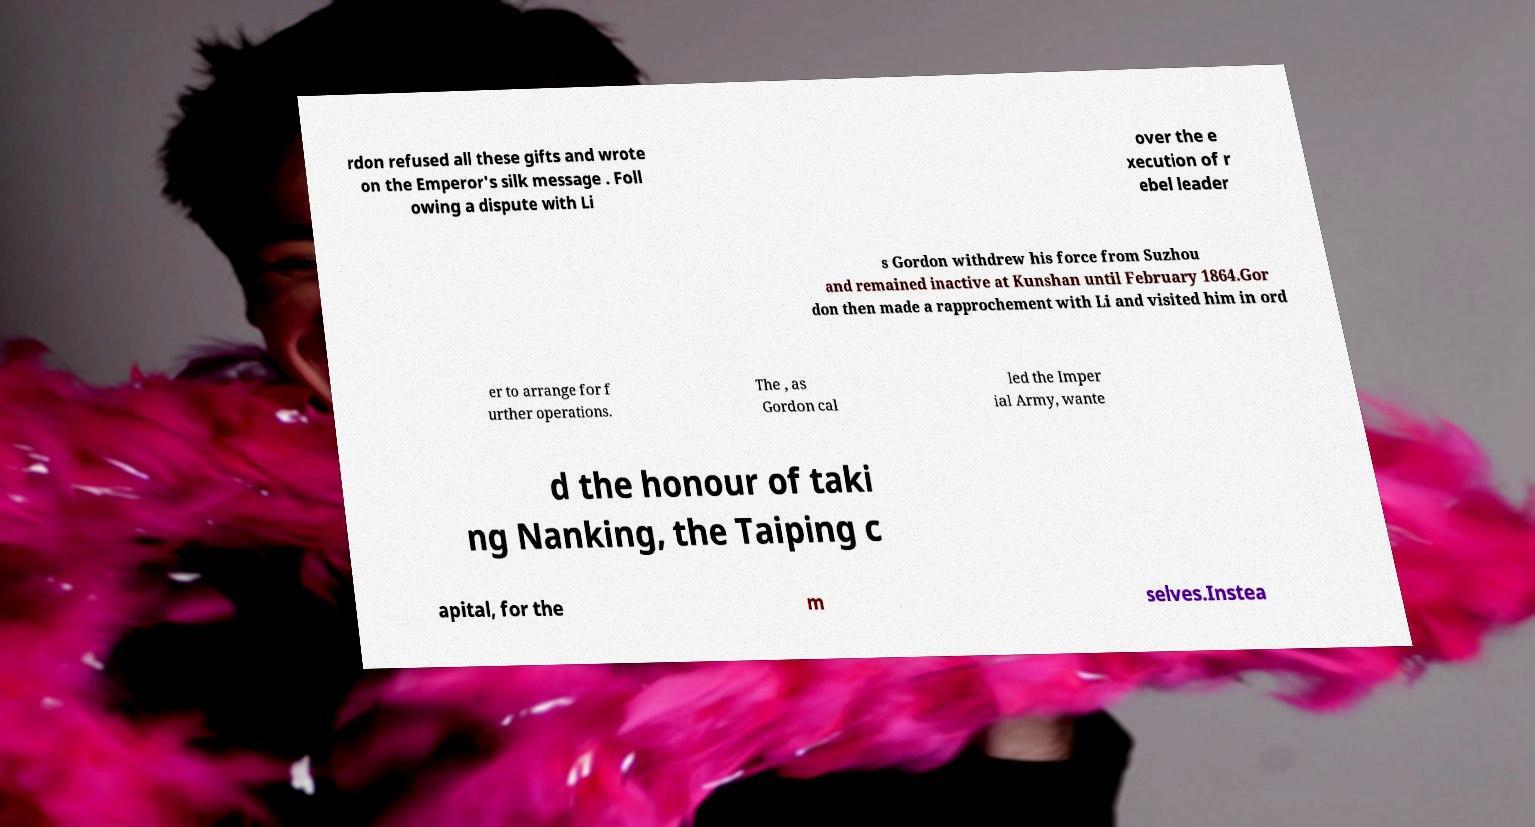Please read and relay the text visible in this image. What does it say? rdon refused all these gifts and wrote on the Emperor's silk message . Foll owing a dispute with Li over the e xecution of r ebel leader s Gordon withdrew his force from Suzhou and remained inactive at Kunshan until February 1864.Gor don then made a rapprochement with Li and visited him in ord er to arrange for f urther operations. The , as Gordon cal led the Imper ial Army, wante d the honour of taki ng Nanking, the Taiping c apital, for the m selves.Instea 